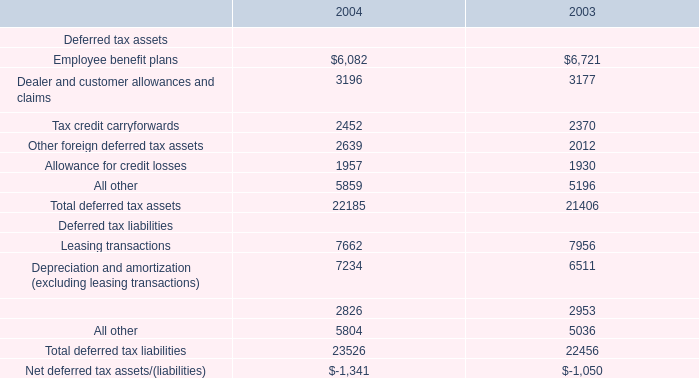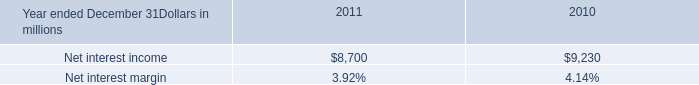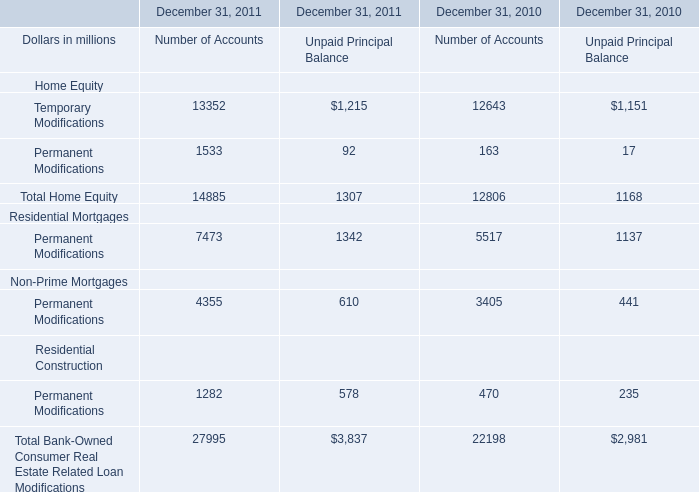what's the total amount of Net interest income of 2011, and All other of 2004 ? 
Computations: (8700.0 + 5859.0)
Answer: 14559.0. 